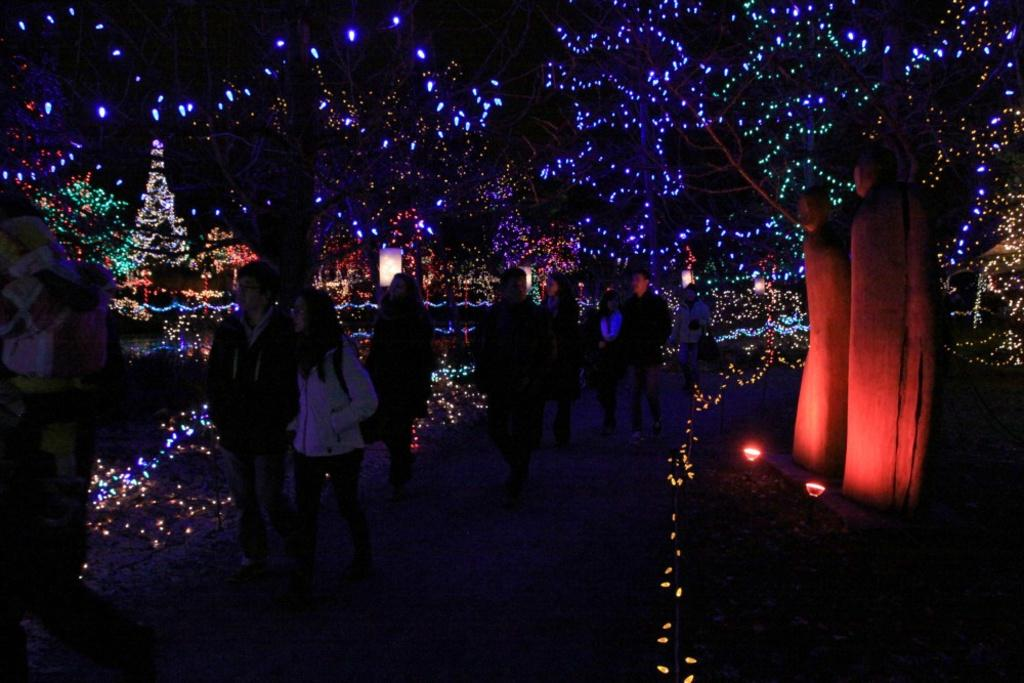What type of decoration can be seen in the image? There are Christmas lights in the image. What are the people in the image doing? People are walking on a pathway in the image. What can be seen on the right side of the image? There is tree bark on the right side of the image. What type of produce is being sold in the image? There is no produce or indication of a business selling produce in the image. Can you see any bones in the image? There are no bones present in the image. 